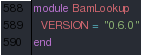<code> <loc_0><loc_0><loc_500><loc_500><_Ruby_>module BamLookup
  VERSION = "0.6.0"
end
</code> 